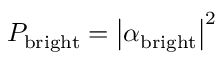Convert formula to latex. <formula><loc_0><loc_0><loc_500><loc_500>P _ { b r i g h t } = \left | \alpha _ { b r i g h t } \right | ^ { 2 }</formula> 